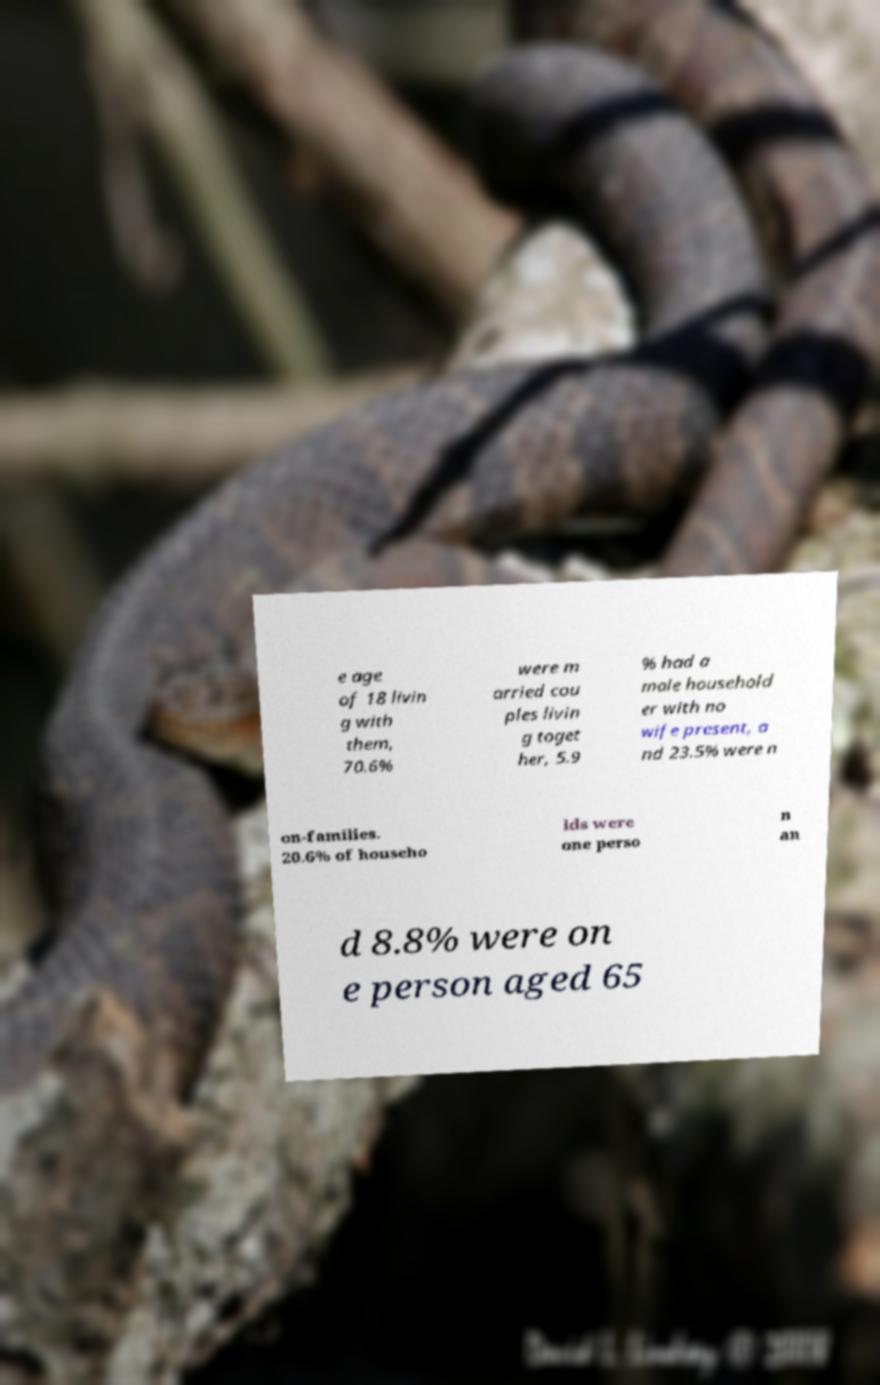Can you read and provide the text displayed in the image?This photo seems to have some interesting text. Can you extract and type it out for me? e age of 18 livin g with them, 70.6% were m arried cou ples livin g toget her, 5.9 % had a male household er with no wife present, a nd 23.5% were n on-families. 20.6% of househo lds were one perso n an d 8.8% were on e person aged 65 